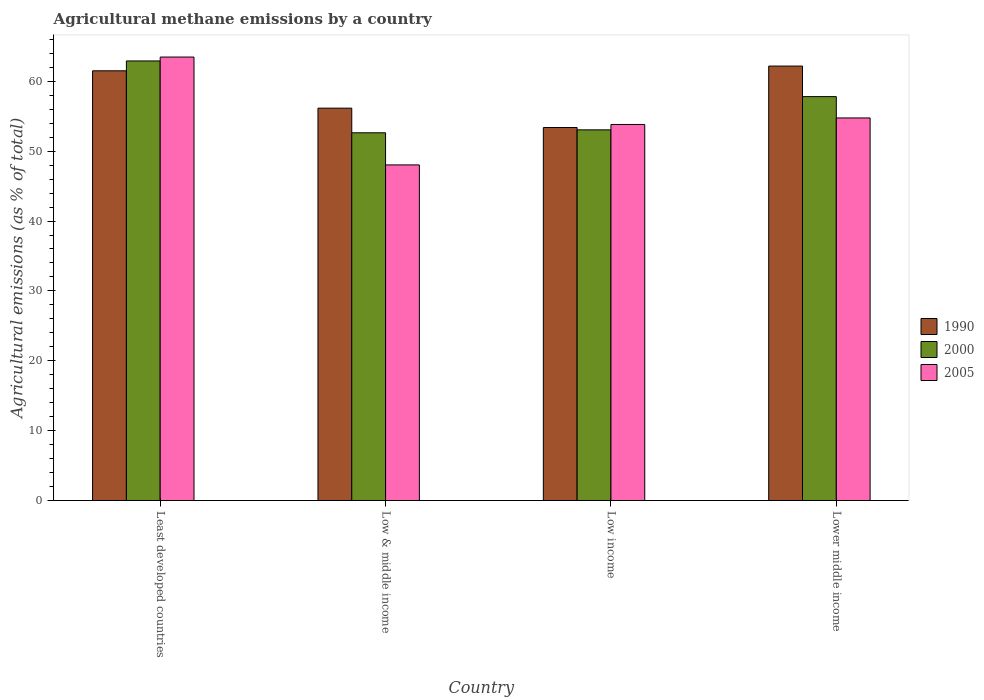Are the number of bars per tick equal to the number of legend labels?
Keep it short and to the point. Yes. Are the number of bars on each tick of the X-axis equal?
Provide a short and direct response. Yes. How many bars are there on the 2nd tick from the left?
Provide a short and direct response. 3. How many bars are there on the 4th tick from the right?
Make the answer very short. 3. What is the label of the 1st group of bars from the left?
Offer a terse response. Least developed countries. In how many cases, is the number of bars for a given country not equal to the number of legend labels?
Make the answer very short. 0. What is the amount of agricultural methane emitted in 2000 in Low & middle income?
Your answer should be very brief. 52.63. Across all countries, what is the maximum amount of agricultural methane emitted in 2000?
Give a very brief answer. 62.92. Across all countries, what is the minimum amount of agricultural methane emitted in 2005?
Provide a short and direct response. 48.04. In which country was the amount of agricultural methane emitted in 1990 maximum?
Provide a short and direct response. Lower middle income. What is the total amount of agricultural methane emitted in 1990 in the graph?
Your response must be concise. 233.24. What is the difference between the amount of agricultural methane emitted in 1990 in Least developed countries and that in Low & middle income?
Your answer should be very brief. 5.35. What is the difference between the amount of agricultural methane emitted in 2000 in Low & middle income and the amount of agricultural methane emitted in 2005 in Lower middle income?
Offer a terse response. -2.12. What is the average amount of agricultural methane emitted in 2000 per country?
Your response must be concise. 56.61. What is the difference between the amount of agricultural methane emitted of/in 2005 and amount of agricultural methane emitted of/in 1990 in Low income?
Make the answer very short. 0.44. In how many countries, is the amount of agricultural methane emitted in 1990 greater than 44 %?
Your answer should be compact. 4. What is the ratio of the amount of agricultural methane emitted in 1990 in Low income to that in Lower middle income?
Make the answer very short. 0.86. Is the difference between the amount of agricultural methane emitted in 2005 in Low & middle income and Lower middle income greater than the difference between the amount of agricultural methane emitted in 1990 in Low & middle income and Lower middle income?
Provide a succinct answer. No. What is the difference between the highest and the second highest amount of agricultural methane emitted in 1990?
Your response must be concise. -5.35. What is the difference between the highest and the lowest amount of agricultural methane emitted in 1990?
Your answer should be compact. 8.8. Is the sum of the amount of agricultural methane emitted in 2005 in Low & middle income and Low income greater than the maximum amount of agricultural methane emitted in 2000 across all countries?
Give a very brief answer. Yes. What does the 1st bar from the left in Low & middle income represents?
Your response must be concise. 1990. What does the 3rd bar from the right in Lower middle income represents?
Provide a succinct answer. 1990. How many countries are there in the graph?
Provide a succinct answer. 4. Are the values on the major ticks of Y-axis written in scientific E-notation?
Give a very brief answer. No. Does the graph contain grids?
Offer a terse response. No. Where does the legend appear in the graph?
Make the answer very short. Center right. How many legend labels are there?
Provide a short and direct response. 3. What is the title of the graph?
Provide a short and direct response. Agricultural methane emissions by a country. Does "1974" appear as one of the legend labels in the graph?
Your answer should be very brief. No. What is the label or title of the X-axis?
Keep it short and to the point. Country. What is the label or title of the Y-axis?
Keep it short and to the point. Agricultural emissions (as % of total). What is the Agricultural emissions (as % of total) of 1990 in Least developed countries?
Ensure brevity in your answer.  61.51. What is the Agricultural emissions (as % of total) in 2000 in Least developed countries?
Keep it short and to the point. 62.92. What is the Agricultural emissions (as % of total) in 2005 in Least developed countries?
Ensure brevity in your answer.  63.48. What is the Agricultural emissions (as % of total) of 1990 in Low & middle income?
Provide a short and direct response. 56.16. What is the Agricultural emissions (as % of total) of 2000 in Low & middle income?
Make the answer very short. 52.63. What is the Agricultural emissions (as % of total) in 2005 in Low & middle income?
Keep it short and to the point. 48.04. What is the Agricultural emissions (as % of total) of 1990 in Low income?
Provide a short and direct response. 53.39. What is the Agricultural emissions (as % of total) in 2000 in Low income?
Your answer should be very brief. 53.05. What is the Agricultural emissions (as % of total) of 2005 in Low income?
Ensure brevity in your answer.  53.82. What is the Agricultural emissions (as % of total) of 1990 in Lower middle income?
Your answer should be compact. 62.18. What is the Agricultural emissions (as % of total) of 2000 in Lower middle income?
Your response must be concise. 57.81. What is the Agricultural emissions (as % of total) of 2005 in Lower middle income?
Ensure brevity in your answer.  54.76. Across all countries, what is the maximum Agricultural emissions (as % of total) of 1990?
Keep it short and to the point. 62.18. Across all countries, what is the maximum Agricultural emissions (as % of total) of 2000?
Give a very brief answer. 62.92. Across all countries, what is the maximum Agricultural emissions (as % of total) of 2005?
Offer a terse response. 63.48. Across all countries, what is the minimum Agricultural emissions (as % of total) in 1990?
Your response must be concise. 53.39. Across all countries, what is the minimum Agricultural emissions (as % of total) in 2000?
Your answer should be compact. 52.63. Across all countries, what is the minimum Agricultural emissions (as % of total) in 2005?
Make the answer very short. 48.04. What is the total Agricultural emissions (as % of total) in 1990 in the graph?
Provide a succinct answer. 233.24. What is the total Agricultural emissions (as % of total) of 2000 in the graph?
Keep it short and to the point. 226.42. What is the total Agricultural emissions (as % of total) of 2005 in the graph?
Your answer should be very brief. 220.1. What is the difference between the Agricultural emissions (as % of total) of 1990 in Least developed countries and that in Low & middle income?
Ensure brevity in your answer.  5.35. What is the difference between the Agricultural emissions (as % of total) in 2000 in Least developed countries and that in Low & middle income?
Your answer should be compact. 10.28. What is the difference between the Agricultural emissions (as % of total) in 2005 in Least developed countries and that in Low & middle income?
Your answer should be very brief. 15.44. What is the difference between the Agricultural emissions (as % of total) in 1990 in Least developed countries and that in Low income?
Make the answer very short. 8.12. What is the difference between the Agricultural emissions (as % of total) of 2000 in Least developed countries and that in Low income?
Your answer should be very brief. 9.86. What is the difference between the Agricultural emissions (as % of total) in 2005 in Least developed countries and that in Low income?
Keep it short and to the point. 9.65. What is the difference between the Agricultural emissions (as % of total) of 1990 in Least developed countries and that in Lower middle income?
Provide a succinct answer. -0.68. What is the difference between the Agricultural emissions (as % of total) in 2000 in Least developed countries and that in Lower middle income?
Offer a very short reply. 5.11. What is the difference between the Agricultural emissions (as % of total) of 2005 in Least developed countries and that in Lower middle income?
Offer a very short reply. 8.72. What is the difference between the Agricultural emissions (as % of total) of 1990 in Low & middle income and that in Low income?
Offer a terse response. 2.77. What is the difference between the Agricultural emissions (as % of total) in 2000 in Low & middle income and that in Low income?
Your answer should be very brief. -0.42. What is the difference between the Agricultural emissions (as % of total) of 2005 in Low & middle income and that in Low income?
Give a very brief answer. -5.79. What is the difference between the Agricultural emissions (as % of total) in 1990 in Low & middle income and that in Lower middle income?
Keep it short and to the point. -6.03. What is the difference between the Agricultural emissions (as % of total) in 2000 in Low & middle income and that in Lower middle income?
Your answer should be compact. -5.18. What is the difference between the Agricultural emissions (as % of total) of 2005 in Low & middle income and that in Lower middle income?
Keep it short and to the point. -6.72. What is the difference between the Agricultural emissions (as % of total) in 1990 in Low income and that in Lower middle income?
Offer a very short reply. -8.8. What is the difference between the Agricultural emissions (as % of total) of 2000 in Low income and that in Lower middle income?
Your answer should be very brief. -4.76. What is the difference between the Agricultural emissions (as % of total) in 2005 in Low income and that in Lower middle income?
Keep it short and to the point. -0.94. What is the difference between the Agricultural emissions (as % of total) in 1990 in Least developed countries and the Agricultural emissions (as % of total) in 2000 in Low & middle income?
Your answer should be very brief. 8.87. What is the difference between the Agricultural emissions (as % of total) in 1990 in Least developed countries and the Agricultural emissions (as % of total) in 2005 in Low & middle income?
Provide a succinct answer. 13.47. What is the difference between the Agricultural emissions (as % of total) in 2000 in Least developed countries and the Agricultural emissions (as % of total) in 2005 in Low & middle income?
Ensure brevity in your answer.  14.88. What is the difference between the Agricultural emissions (as % of total) in 1990 in Least developed countries and the Agricultural emissions (as % of total) in 2000 in Low income?
Offer a terse response. 8.45. What is the difference between the Agricultural emissions (as % of total) of 1990 in Least developed countries and the Agricultural emissions (as % of total) of 2005 in Low income?
Give a very brief answer. 7.68. What is the difference between the Agricultural emissions (as % of total) of 2000 in Least developed countries and the Agricultural emissions (as % of total) of 2005 in Low income?
Ensure brevity in your answer.  9.09. What is the difference between the Agricultural emissions (as % of total) of 1990 in Least developed countries and the Agricultural emissions (as % of total) of 2000 in Lower middle income?
Provide a succinct answer. 3.69. What is the difference between the Agricultural emissions (as % of total) of 1990 in Least developed countries and the Agricultural emissions (as % of total) of 2005 in Lower middle income?
Provide a succinct answer. 6.75. What is the difference between the Agricultural emissions (as % of total) of 2000 in Least developed countries and the Agricultural emissions (as % of total) of 2005 in Lower middle income?
Offer a very short reply. 8.16. What is the difference between the Agricultural emissions (as % of total) in 1990 in Low & middle income and the Agricultural emissions (as % of total) in 2000 in Low income?
Ensure brevity in your answer.  3.1. What is the difference between the Agricultural emissions (as % of total) of 1990 in Low & middle income and the Agricultural emissions (as % of total) of 2005 in Low income?
Provide a succinct answer. 2.33. What is the difference between the Agricultural emissions (as % of total) of 2000 in Low & middle income and the Agricultural emissions (as % of total) of 2005 in Low income?
Offer a very short reply. -1.19. What is the difference between the Agricultural emissions (as % of total) of 1990 in Low & middle income and the Agricultural emissions (as % of total) of 2000 in Lower middle income?
Your answer should be very brief. -1.65. What is the difference between the Agricultural emissions (as % of total) of 1990 in Low & middle income and the Agricultural emissions (as % of total) of 2005 in Lower middle income?
Provide a short and direct response. 1.4. What is the difference between the Agricultural emissions (as % of total) in 2000 in Low & middle income and the Agricultural emissions (as % of total) in 2005 in Lower middle income?
Ensure brevity in your answer.  -2.12. What is the difference between the Agricultural emissions (as % of total) in 1990 in Low income and the Agricultural emissions (as % of total) in 2000 in Lower middle income?
Offer a terse response. -4.42. What is the difference between the Agricultural emissions (as % of total) of 1990 in Low income and the Agricultural emissions (as % of total) of 2005 in Lower middle income?
Provide a succinct answer. -1.37. What is the difference between the Agricultural emissions (as % of total) in 2000 in Low income and the Agricultural emissions (as % of total) in 2005 in Lower middle income?
Keep it short and to the point. -1.7. What is the average Agricultural emissions (as % of total) in 1990 per country?
Give a very brief answer. 58.31. What is the average Agricultural emissions (as % of total) of 2000 per country?
Provide a short and direct response. 56.61. What is the average Agricultural emissions (as % of total) of 2005 per country?
Give a very brief answer. 55.02. What is the difference between the Agricultural emissions (as % of total) in 1990 and Agricultural emissions (as % of total) in 2000 in Least developed countries?
Make the answer very short. -1.41. What is the difference between the Agricultural emissions (as % of total) of 1990 and Agricultural emissions (as % of total) of 2005 in Least developed countries?
Your answer should be very brief. -1.97. What is the difference between the Agricultural emissions (as % of total) of 2000 and Agricultural emissions (as % of total) of 2005 in Least developed countries?
Make the answer very short. -0.56. What is the difference between the Agricultural emissions (as % of total) in 1990 and Agricultural emissions (as % of total) in 2000 in Low & middle income?
Provide a short and direct response. 3.52. What is the difference between the Agricultural emissions (as % of total) of 1990 and Agricultural emissions (as % of total) of 2005 in Low & middle income?
Give a very brief answer. 8.12. What is the difference between the Agricultural emissions (as % of total) in 2000 and Agricultural emissions (as % of total) in 2005 in Low & middle income?
Ensure brevity in your answer.  4.6. What is the difference between the Agricultural emissions (as % of total) of 1990 and Agricultural emissions (as % of total) of 2000 in Low income?
Your answer should be very brief. 0.33. What is the difference between the Agricultural emissions (as % of total) in 1990 and Agricultural emissions (as % of total) in 2005 in Low income?
Your answer should be compact. -0.44. What is the difference between the Agricultural emissions (as % of total) in 2000 and Agricultural emissions (as % of total) in 2005 in Low income?
Give a very brief answer. -0.77. What is the difference between the Agricultural emissions (as % of total) in 1990 and Agricultural emissions (as % of total) in 2000 in Lower middle income?
Keep it short and to the point. 4.37. What is the difference between the Agricultural emissions (as % of total) of 1990 and Agricultural emissions (as % of total) of 2005 in Lower middle income?
Ensure brevity in your answer.  7.42. What is the difference between the Agricultural emissions (as % of total) in 2000 and Agricultural emissions (as % of total) in 2005 in Lower middle income?
Offer a very short reply. 3.05. What is the ratio of the Agricultural emissions (as % of total) of 1990 in Least developed countries to that in Low & middle income?
Keep it short and to the point. 1.1. What is the ratio of the Agricultural emissions (as % of total) in 2000 in Least developed countries to that in Low & middle income?
Make the answer very short. 1.2. What is the ratio of the Agricultural emissions (as % of total) of 2005 in Least developed countries to that in Low & middle income?
Your answer should be compact. 1.32. What is the ratio of the Agricultural emissions (as % of total) in 1990 in Least developed countries to that in Low income?
Your answer should be compact. 1.15. What is the ratio of the Agricultural emissions (as % of total) of 2000 in Least developed countries to that in Low income?
Offer a terse response. 1.19. What is the ratio of the Agricultural emissions (as % of total) of 2005 in Least developed countries to that in Low income?
Give a very brief answer. 1.18. What is the ratio of the Agricultural emissions (as % of total) of 1990 in Least developed countries to that in Lower middle income?
Ensure brevity in your answer.  0.99. What is the ratio of the Agricultural emissions (as % of total) of 2000 in Least developed countries to that in Lower middle income?
Keep it short and to the point. 1.09. What is the ratio of the Agricultural emissions (as % of total) in 2005 in Least developed countries to that in Lower middle income?
Provide a succinct answer. 1.16. What is the ratio of the Agricultural emissions (as % of total) of 1990 in Low & middle income to that in Low income?
Give a very brief answer. 1.05. What is the ratio of the Agricultural emissions (as % of total) of 2000 in Low & middle income to that in Low income?
Your answer should be very brief. 0.99. What is the ratio of the Agricultural emissions (as % of total) in 2005 in Low & middle income to that in Low income?
Your response must be concise. 0.89. What is the ratio of the Agricultural emissions (as % of total) of 1990 in Low & middle income to that in Lower middle income?
Your answer should be compact. 0.9. What is the ratio of the Agricultural emissions (as % of total) of 2000 in Low & middle income to that in Lower middle income?
Keep it short and to the point. 0.91. What is the ratio of the Agricultural emissions (as % of total) in 2005 in Low & middle income to that in Lower middle income?
Provide a succinct answer. 0.88. What is the ratio of the Agricultural emissions (as % of total) in 1990 in Low income to that in Lower middle income?
Your response must be concise. 0.86. What is the ratio of the Agricultural emissions (as % of total) in 2000 in Low income to that in Lower middle income?
Ensure brevity in your answer.  0.92. What is the ratio of the Agricultural emissions (as % of total) in 2005 in Low income to that in Lower middle income?
Ensure brevity in your answer.  0.98. What is the difference between the highest and the second highest Agricultural emissions (as % of total) of 1990?
Your response must be concise. 0.68. What is the difference between the highest and the second highest Agricultural emissions (as % of total) of 2000?
Keep it short and to the point. 5.11. What is the difference between the highest and the second highest Agricultural emissions (as % of total) of 2005?
Provide a short and direct response. 8.72. What is the difference between the highest and the lowest Agricultural emissions (as % of total) of 1990?
Provide a succinct answer. 8.8. What is the difference between the highest and the lowest Agricultural emissions (as % of total) in 2000?
Offer a very short reply. 10.28. What is the difference between the highest and the lowest Agricultural emissions (as % of total) of 2005?
Your answer should be very brief. 15.44. 